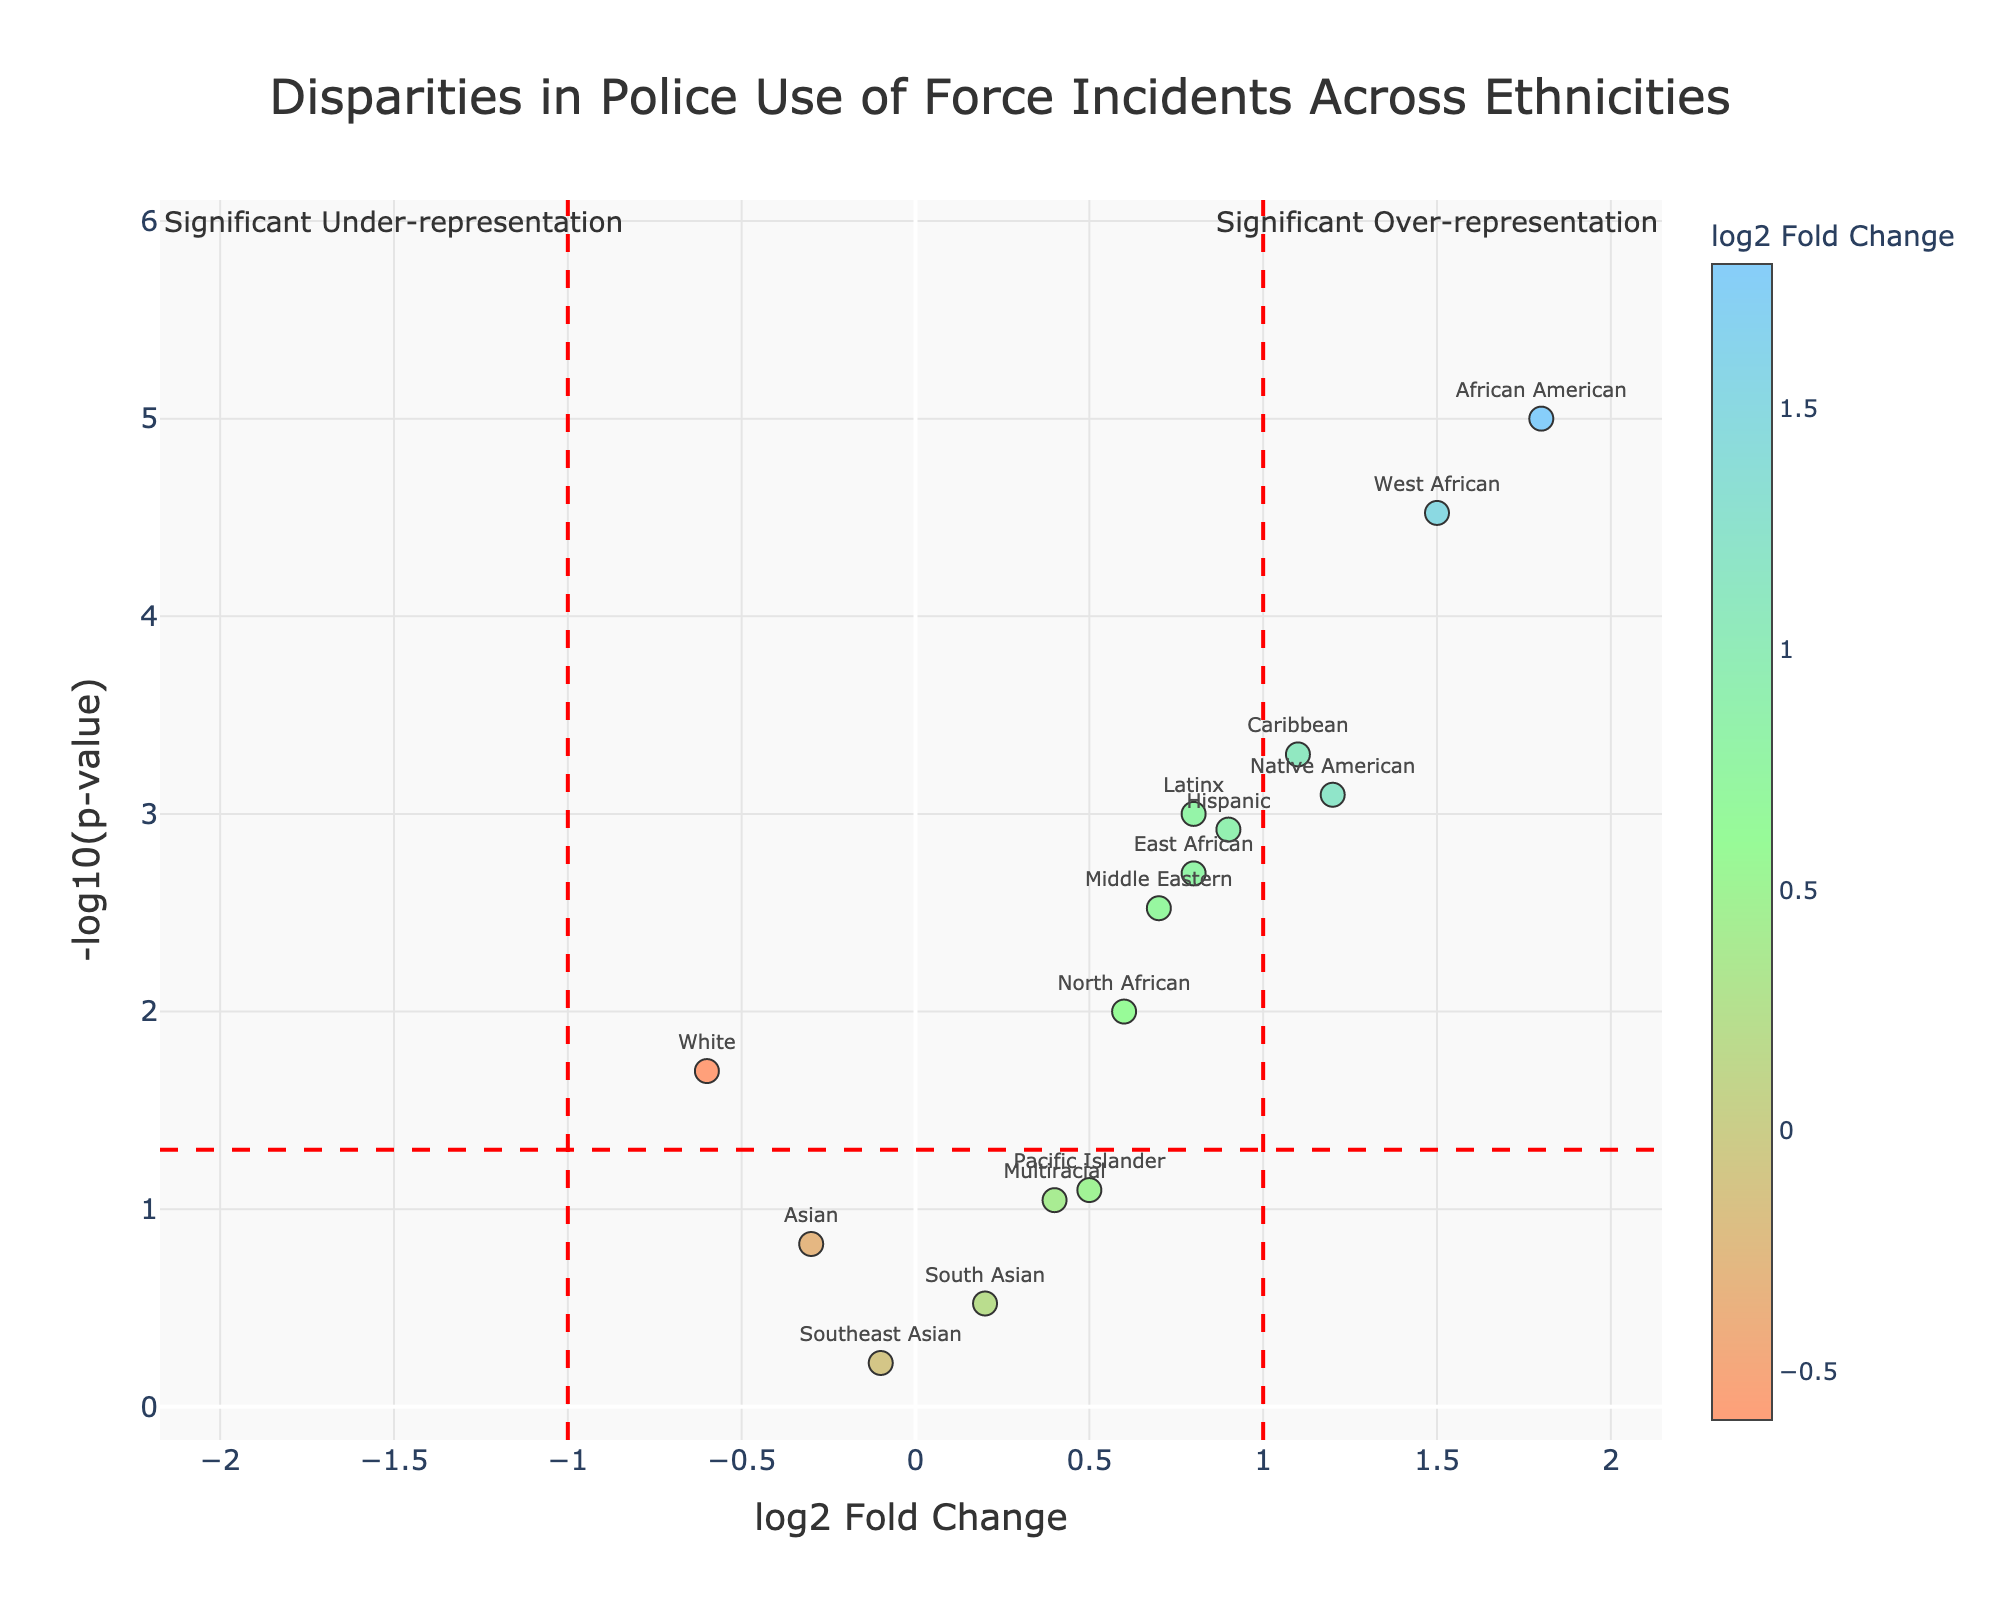How many ethnicities are represented in the plot? Count all distinct ethnicities listed as data points on the plot.
Answer: 14 What is the full title of the plot? Refer to the title displayed at the top of the plot.
Answer: Disparities in Police Use of Force Incidents Across Ethnicities Which ethnicity has the highest log2 fold change value? Find the data point with the maximum value on the x-axis (log2 fold change).
Answer: African American Which ethnicities show statistically significant over-representation? Identify ethnicities with log2 fold change > 1 and -log10(p-value) > 1.3 (p-value < 0.05).
Answer: African American, Native American, Caribbean, West African Which ethnicity has the lowest -log10(p-value) value? Find the data point with the minimum value on the y-axis (-log10(p-value)).
Answer: Southeast Asian What does the red dashed horizontal line represent? Examine the horizontal line and understand its context within the plot. It indicates -log10(p-value) = 1.3 (p-value = 0.05) threshold for significance.
Answer: Significance threshold for p-value Compare the log2 fold change values between 'African American' and 'White'. Which is higher? Locate both data points and compare their x-axis values.
Answer: African American What can we infer about the representation of 'Asian' in police use of force incidents? Look at the log2 fold change and -log10(p-value) values for 'Asian'.
Answer: Under-representation, non-significant What is the log2 fold change for 'Hispanic' ethnicity? Locate the 'Hispanic' data point on the plot and refer to its x-axis value.
Answer: 0.9 Are any ethnicities underrepresented in the police use of force incidents? If yes, name them. Identify data points with log2 fold change < 0 and check their significance by -log10(p-value) > 1.3.
Answer: White 